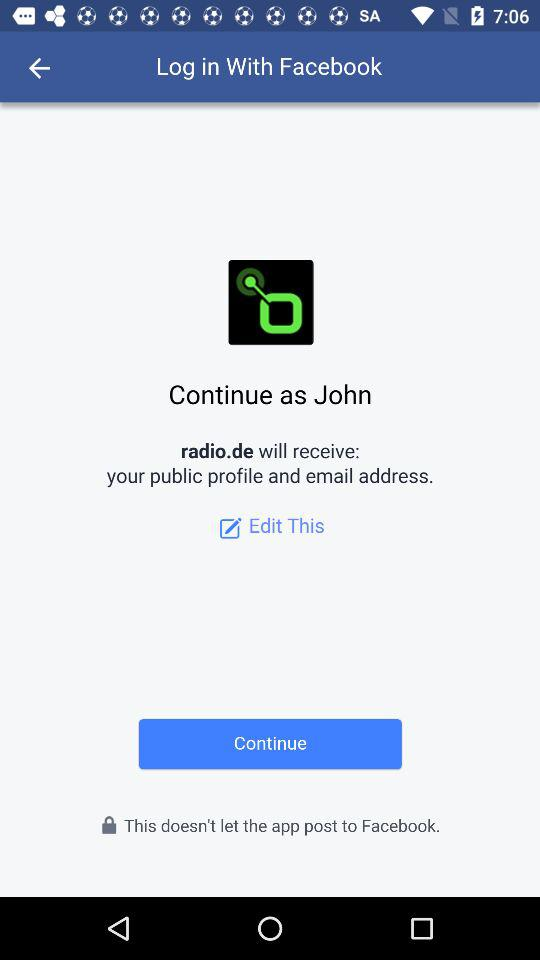What is the name of the user? The name of the user is John. 